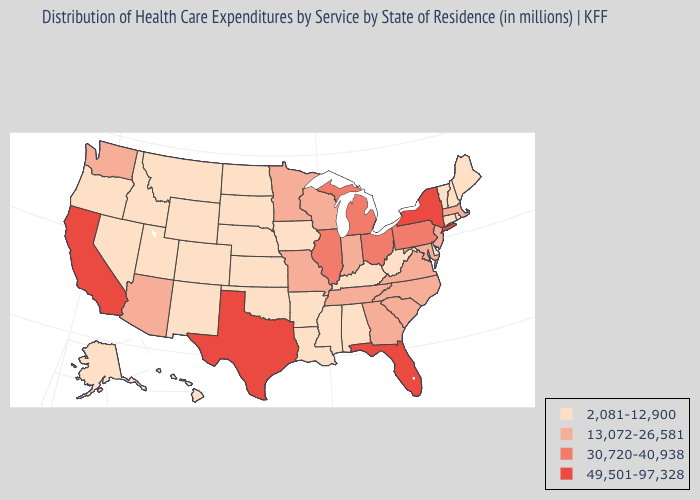What is the highest value in the West ?
Keep it brief. 49,501-97,328. Does Minnesota have a lower value than Florida?
Write a very short answer. Yes. What is the lowest value in the South?
Keep it brief. 2,081-12,900. Does North Carolina have the highest value in the South?
Give a very brief answer. No. Name the states that have a value in the range 30,720-40,938?
Quick response, please. Illinois, Michigan, Ohio, Pennsylvania. Which states have the highest value in the USA?
Short answer required. California, Florida, New York, Texas. What is the lowest value in the USA?
Concise answer only. 2,081-12,900. Name the states that have a value in the range 49,501-97,328?
Write a very short answer. California, Florida, New York, Texas. Which states have the highest value in the USA?
Write a very short answer. California, Florida, New York, Texas. Does North Carolina have a lower value than Ohio?
Quick response, please. Yes. What is the value of Maine?
Quick response, please. 2,081-12,900. Among the states that border Idaho , which have the lowest value?
Write a very short answer. Montana, Nevada, Oregon, Utah, Wyoming. What is the value of Delaware?
Answer briefly. 2,081-12,900. What is the lowest value in the USA?
Concise answer only. 2,081-12,900. Does Alaska have a higher value than North Carolina?
Give a very brief answer. No. 